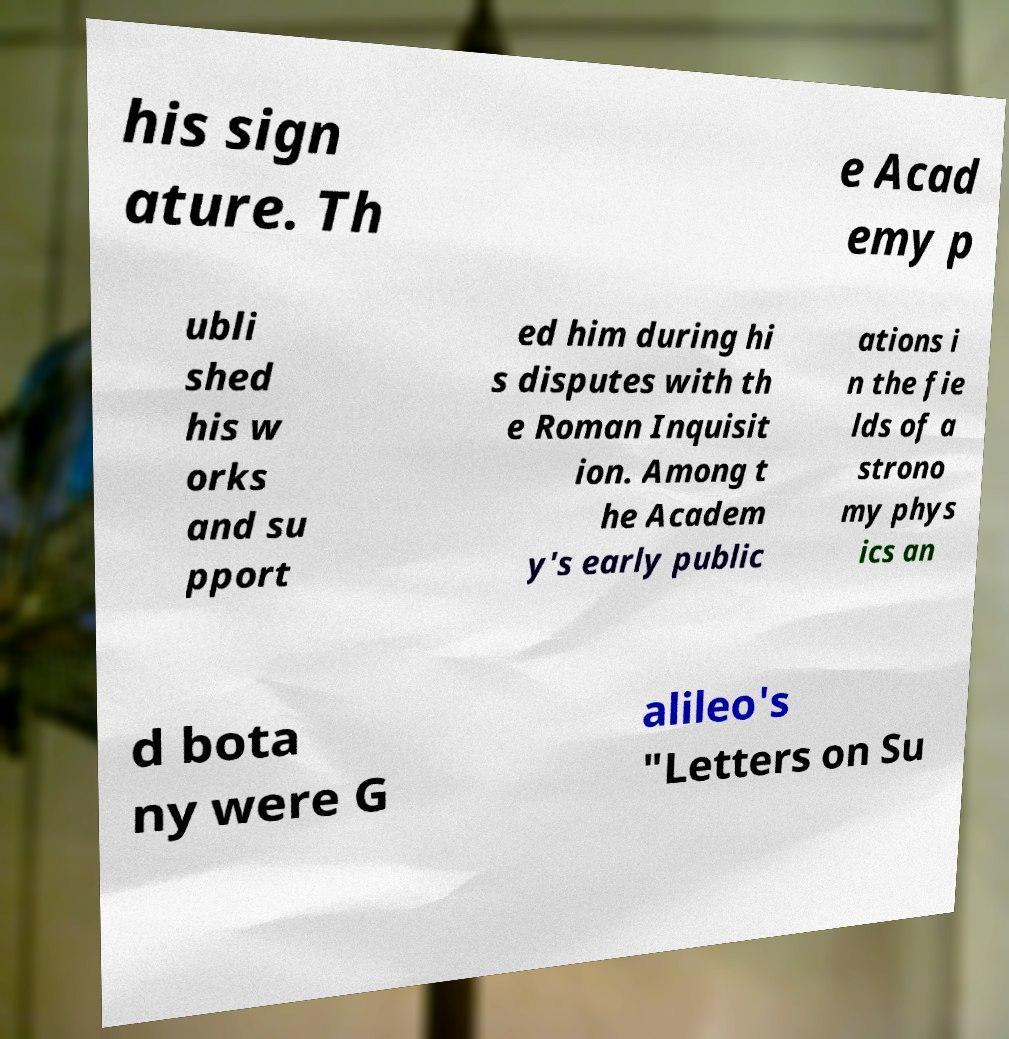What messages or text are displayed in this image? I need them in a readable, typed format. his sign ature. Th e Acad emy p ubli shed his w orks and su pport ed him during hi s disputes with th e Roman Inquisit ion. Among t he Academ y's early public ations i n the fie lds of a strono my phys ics an d bota ny were G alileo's "Letters on Su 